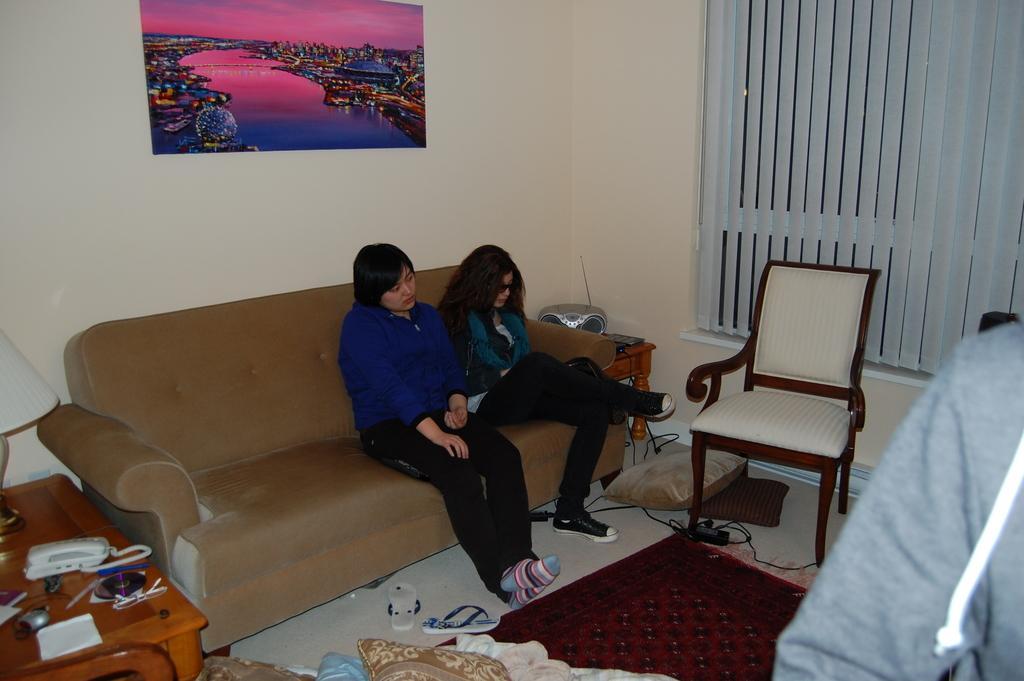Can you describe this image briefly? Two women are sitting on a sofa. 